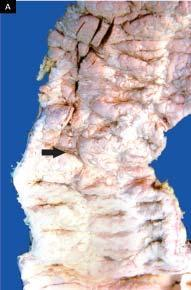did the wall of the stomach in the region of pyloric canal contain necrotic tissue?
Answer the question using a single word or phrase. No 